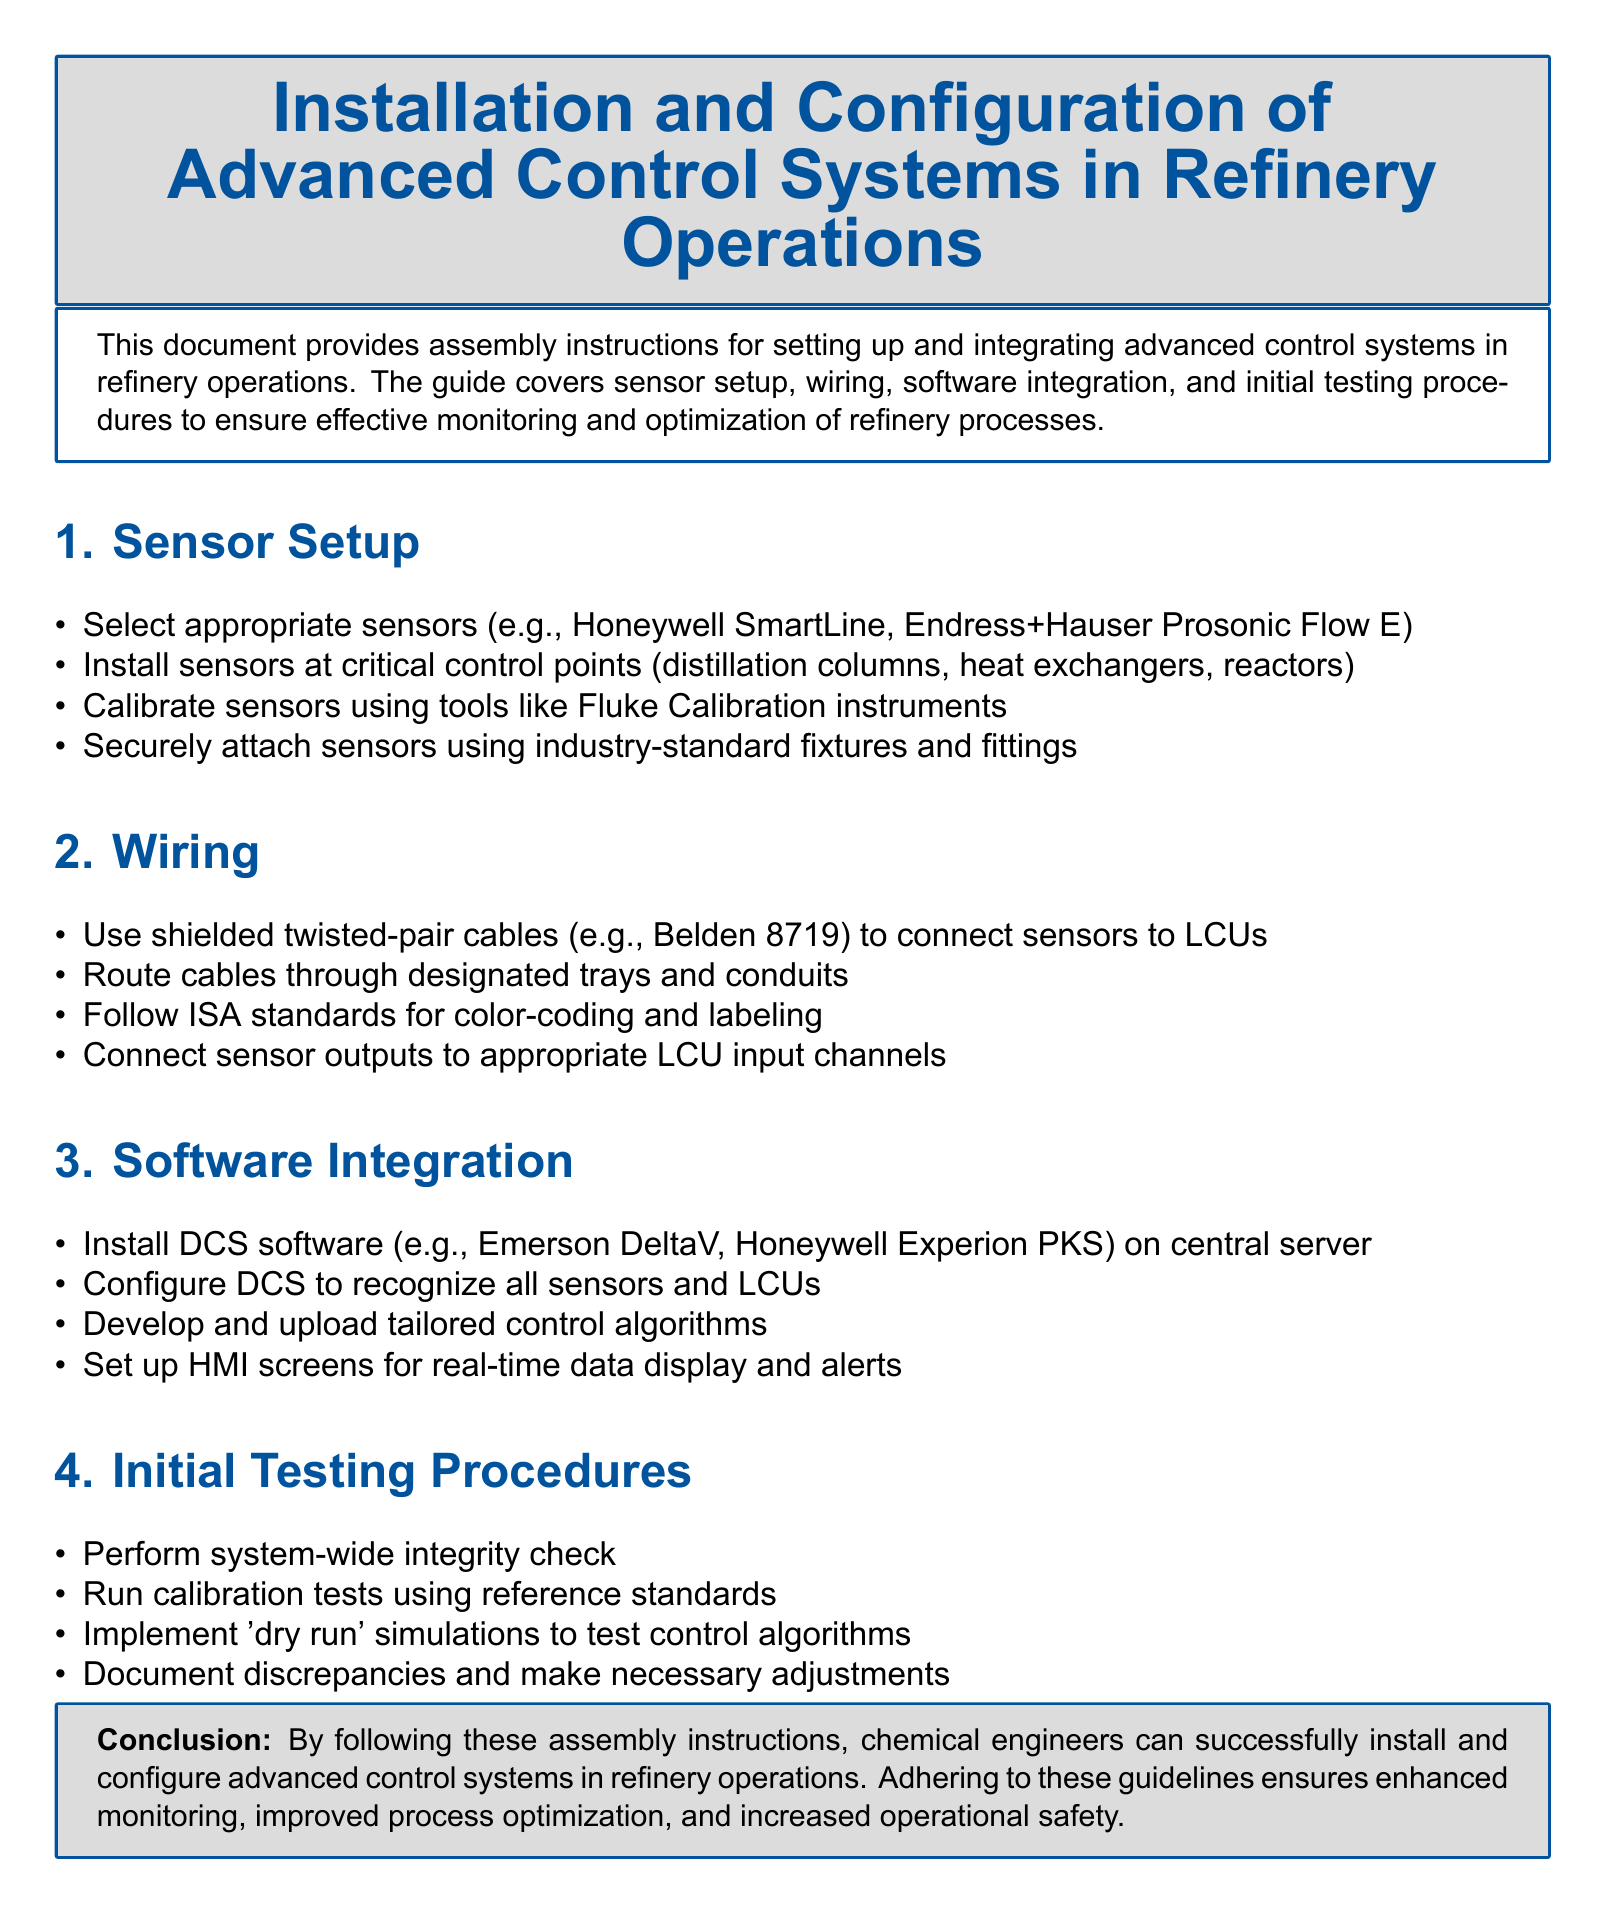What is the first step in sensor setup? The first step in sensor setup is to select appropriate sensors.
Answer: Select appropriate sensors Which DCS software examples are mentioned? Two examples of DCS software mentioned are Emerson DeltaV and Honeywell Experion PKS.
Answer: Emerson DeltaV, Honeywell Experion PKS What type of cables should be used for wiring? The document specifies the use of shielded twisted-pair cables.
Answer: Shielded twisted-pair cables What is performed during initial testing procedures? A system-wide integrity check is performed during initial testing procedures.
Answer: System-wide integrity check How many primary sections are detailed in the document? The document outlines four primary sections: Sensor Setup, Wiring, Software Integration, Initial Testing Procedures.
Answer: Four 